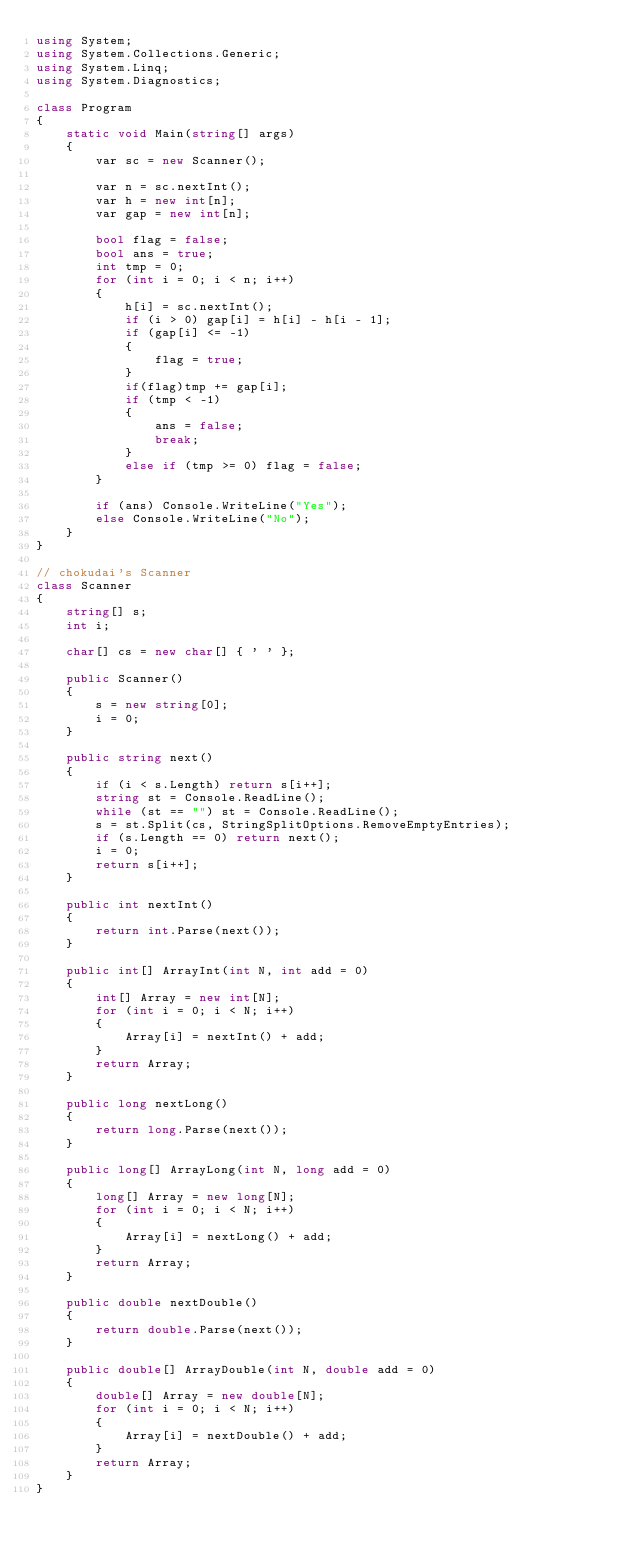Convert code to text. <code><loc_0><loc_0><loc_500><loc_500><_C#_>using System;
using System.Collections.Generic;
using System.Linq;
using System.Diagnostics;

class Program
{
    static void Main(string[] args)
    {
        var sc = new Scanner();

        var n = sc.nextInt();
        var h = new int[n];
        var gap = new int[n];

        bool flag = false;
        bool ans = true;
        int tmp = 0;
        for (int i = 0; i < n; i++)
        {
            h[i] = sc.nextInt();
            if (i > 0) gap[i] = h[i] - h[i - 1];
            if (gap[i] <= -1)
            {
                flag = true;
            }
            if(flag)tmp += gap[i];
            if (tmp < -1)
            {
                ans = false;
                break;
            }
            else if (tmp >= 0) flag = false;
        }

        if (ans) Console.WriteLine("Yes");
        else Console.WriteLine("No");
    }
}

// chokudai's Scanner
class Scanner
{
    string[] s;
    int i;

    char[] cs = new char[] { ' ' };

    public Scanner()
    {
        s = new string[0];
        i = 0;
    }

    public string next()
    {
        if (i < s.Length) return s[i++];
        string st = Console.ReadLine();
        while (st == "") st = Console.ReadLine();
        s = st.Split(cs, StringSplitOptions.RemoveEmptyEntries);
        if (s.Length == 0) return next();
        i = 0;
        return s[i++];
    }

    public int nextInt()
    {
        return int.Parse(next());
    }

    public int[] ArrayInt(int N, int add = 0)
    {
        int[] Array = new int[N];
        for (int i = 0; i < N; i++)
        {
            Array[i] = nextInt() + add;
        }
        return Array;
    }

    public long nextLong()
    {
        return long.Parse(next());
    }

    public long[] ArrayLong(int N, long add = 0)
    {
        long[] Array = new long[N];
        for (int i = 0; i < N; i++)
        {
            Array[i] = nextLong() + add;
        }
        return Array;
    }

    public double nextDouble()
    {
        return double.Parse(next());
    }

    public double[] ArrayDouble(int N, double add = 0)
    {
        double[] Array = new double[N];
        for (int i = 0; i < N; i++)
        {
            Array[i] = nextDouble() + add;
        }
        return Array;
    }
}
</code> 